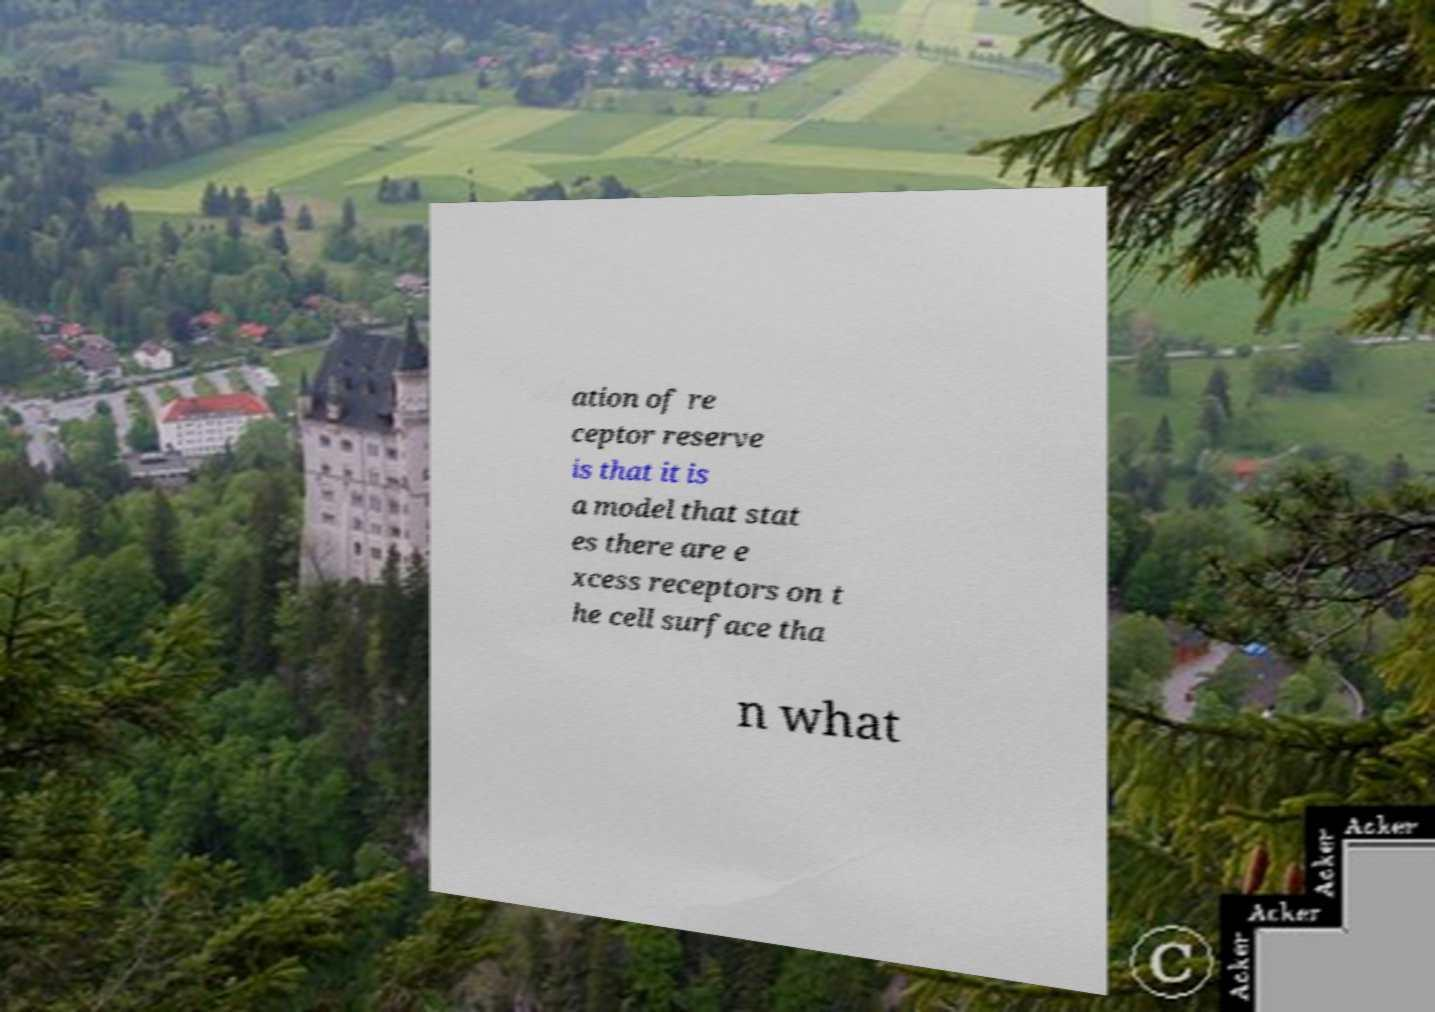For documentation purposes, I need the text within this image transcribed. Could you provide that? ation of re ceptor reserve is that it is a model that stat es there are e xcess receptors on t he cell surface tha n what 